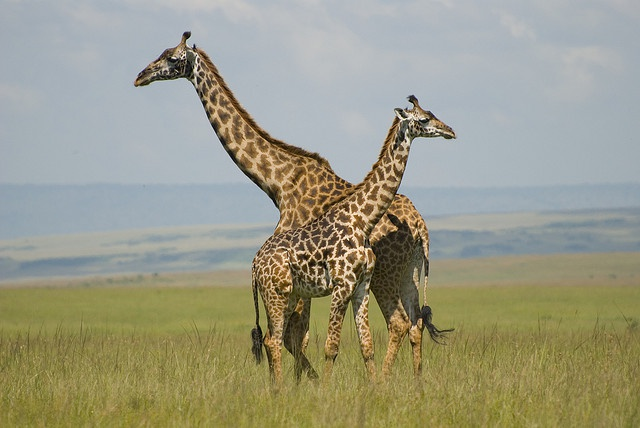Describe the objects in this image and their specific colors. I can see giraffe in darkgray, olive, tan, black, and maroon tones and giraffe in darkgray, olive, black, and tan tones in this image. 